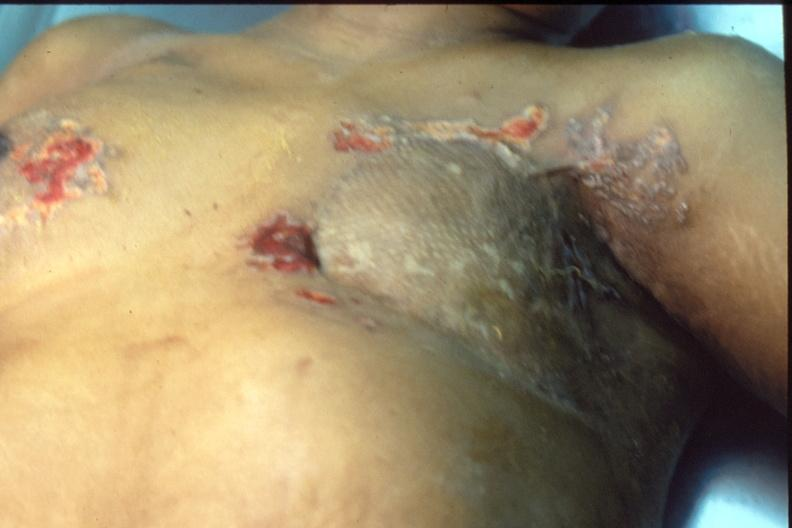s breast present?
Answer the question using a single word or phrase. Yes 